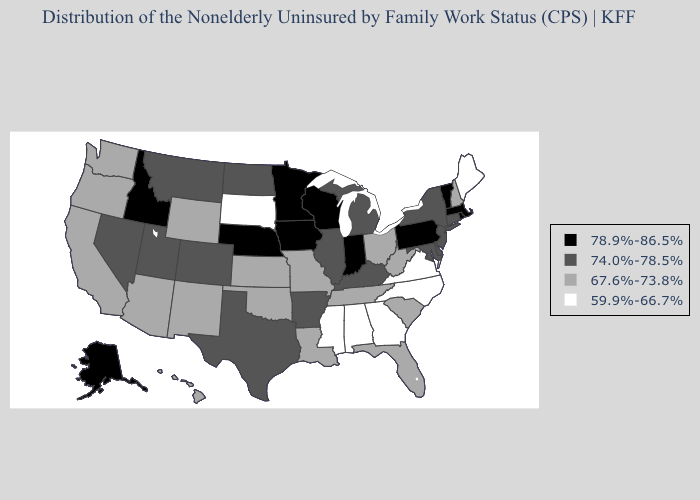Name the states that have a value in the range 74.0%-78.5%?
Short answer required. Arkansas, Colorado, Connecticut, Delaware, Illinois, Kentucky, Maryland, Michigan, Montana, Nevada, New Jersey, New York, North Dakota, Texas, Utah. Among the states that border South Dakota , which have the highest value?
Quick response, please. Iowa, Minnesota, Nebraska. What is the lowest value in states that border New Hampshire?
Be succinct. 59.9%-66.7%. Name the states that have a value in the range 78.9%-86.5%?
Concise answer only. Alaska, Idaho, Indiana, Iowa, Massachusetts, Minnesota, Nebraska, Pennsylvania, Rhode Island, Vermont, Wisconsin. Among the states that border Mississippi , does Louisiana have the highest value?
Keep it brief. No. Name the states that have a value in the range 67.6%-73.8%?
Answer briefly. Arizona, California, Florida, Hawaii, Kansas, Louisiana, Missouri, New Hampshire, New Mexico, Ohio, Oklahoma, Oregon, South Carolina, Tennessee, Washington, West Virginia, Wyoming. Among the states that border New York , which have the highest value?
Short answer required. Massachusetts, Pennsylvania, Vermont. Which states have the lowest value in the USA?
Give a very brief answer. Alabama, Georgia, Maine, Mississippi, North Carolina, South Dakota, Virginia. What is the highest value in the USA?
Be succinct. 78.9%-86.5%. Among the states that border Indiana , which have the highest value?
Be succinct. Illinois, Kentucky, Michigan. Which states have the highest value in the USA?
Quick response, please. Alaska, Idaho, Indiana, Iowa, Massachusetts, Minnesota, Nebraska, Pennsylvania, Rhode Island, Vermont, Wisconsin. Name the states that have a value in the range 67.6%-73.8%?
Be succinct. Arizona, California, Florida, Hawaii, Kansas, Louisiana, Missouri, New Hampshire, New Mexico, Ohio, Oklahoma, Oregon, South Carolina, Tennessee, Washington, West Virginia, Wyoming. What is the value of Missouri?
Be succinct. 67.6%-73.8%. What is the value of New Jersey?
Keep it brief. 74.0%-78.5%. Does Michigan have the highest value in the USA?
Quick response, please. No. 